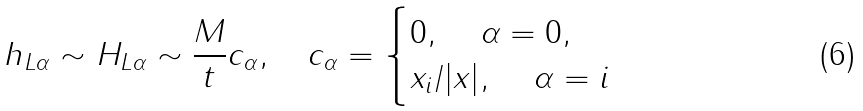Convert formula to latex. <formula><loc_0><loc_0><loc_500><loc_500>h _ { L \alpha } \sim H _ { L \alpha } \sim \frac { M } t c _ { \alpha } , \quad c _ { \alpha } = \begin{cases} 0 , \quad \, \alpha = 0 , \\ { x _ { i } } / { | x | } , \quad \, \alpha = i \end{cases}</formula> 